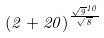<formula> <loc_0><loc_0><loc_500><loc_500>( 2 + 2 0 ) ^ { \frac { \sqrt { 9 } ^ { 1 0 } } { \sqrt { 8 } } }</formula> 